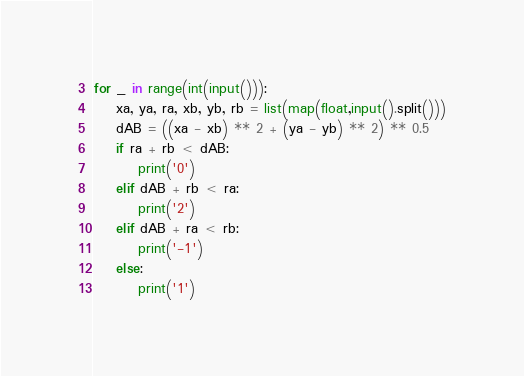Convert code to text. <code><loc_0><loc_0><loc_500><loc_500><_Python_>for _ in range(int(input())):
    xa, ya, ra, xb, yb, rb = list(map(float,input().split()))
    dAB = ((xa - xb) ** 2 + (ya - yb) ** 2) ** 0.5
    if ra + rb < dAB:
        print('0')
    elif dAB + rb < ra:
        print('2')
    elif dAB + ra < rb:
        print('-1')
    else:
        print('1')</code> 